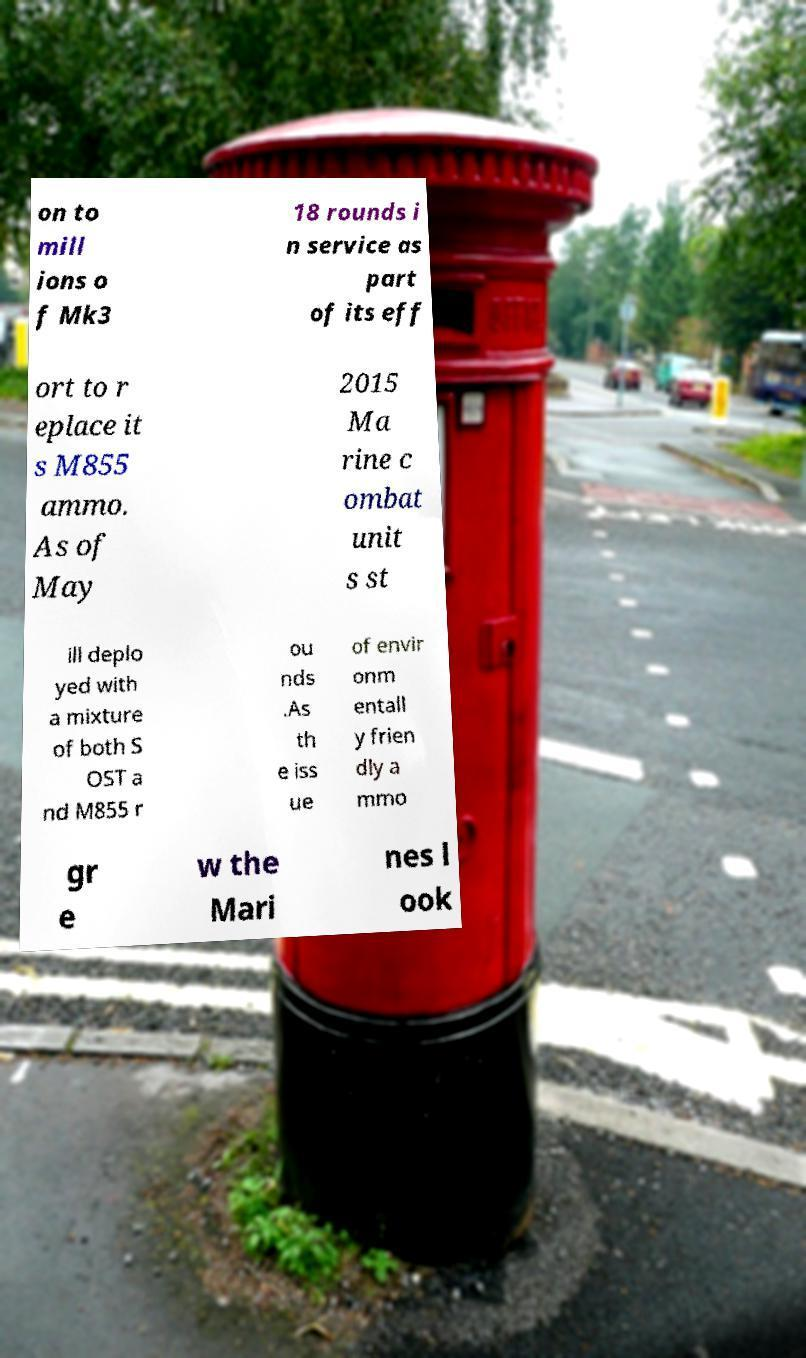Can you read and provide the text displayed in the image?This photo seems to have some interesting text. Can you extract and type it out for me? on to mill ions o f Mk3 18 rounds i n service as part of its eff ort to r eplace it s M855 ammo. As of May 2015 Ma rine c ombat unit s st ill deplo yed with a mixture of both S OST a nd M855 r ou nds .As th e iss ue of envir onm entall y frien dly a mmo gr e w the Mari nes l ook 